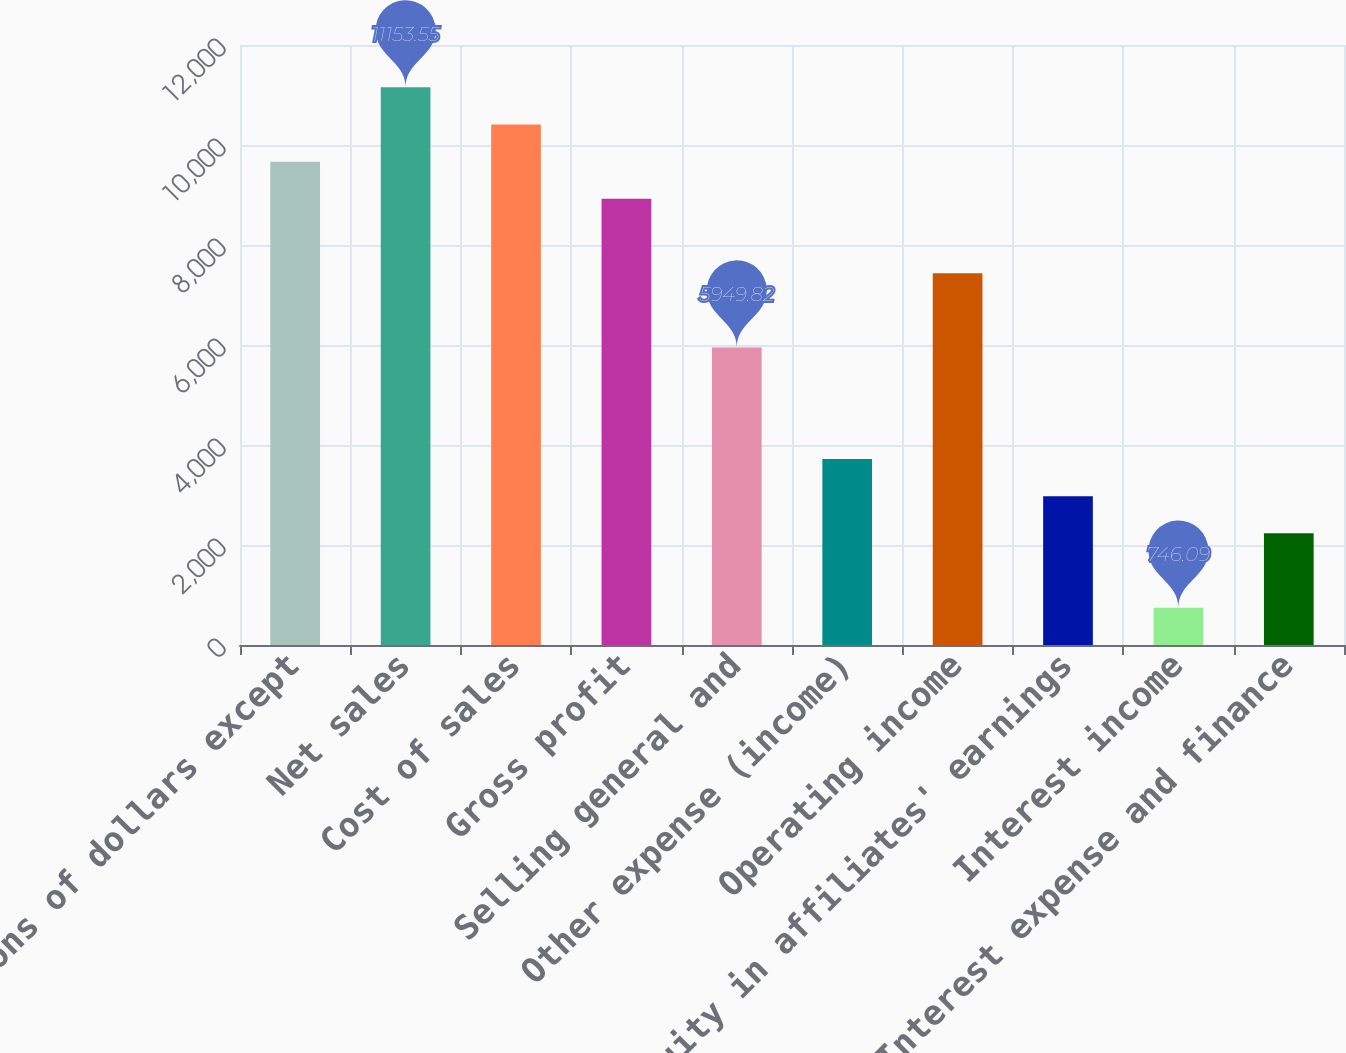Convert chart to OTSL. <chart><loc_0><loc_0><loc_500><loc_500><bar_chart><fcel>(millions of dollars except<fcel>Net sales<fcel>Cost of sales<fcel>Gross profit<fcel>Selling general and<fcel>Other expense (income)<fcel>Operating income<fcel>Equity in affiliates' earnings<fcel>Interest income<fcel>Interest expense and finance<nl><fcel>9666.77<fcel>11153.5<fcel>10410.2<fcel>8923.38<fcel>5949.82<fcel>3719.65<fcel>7436.6<fcel>2976.26<fcel>746.09<fcel>2232.87<nl></chart> 